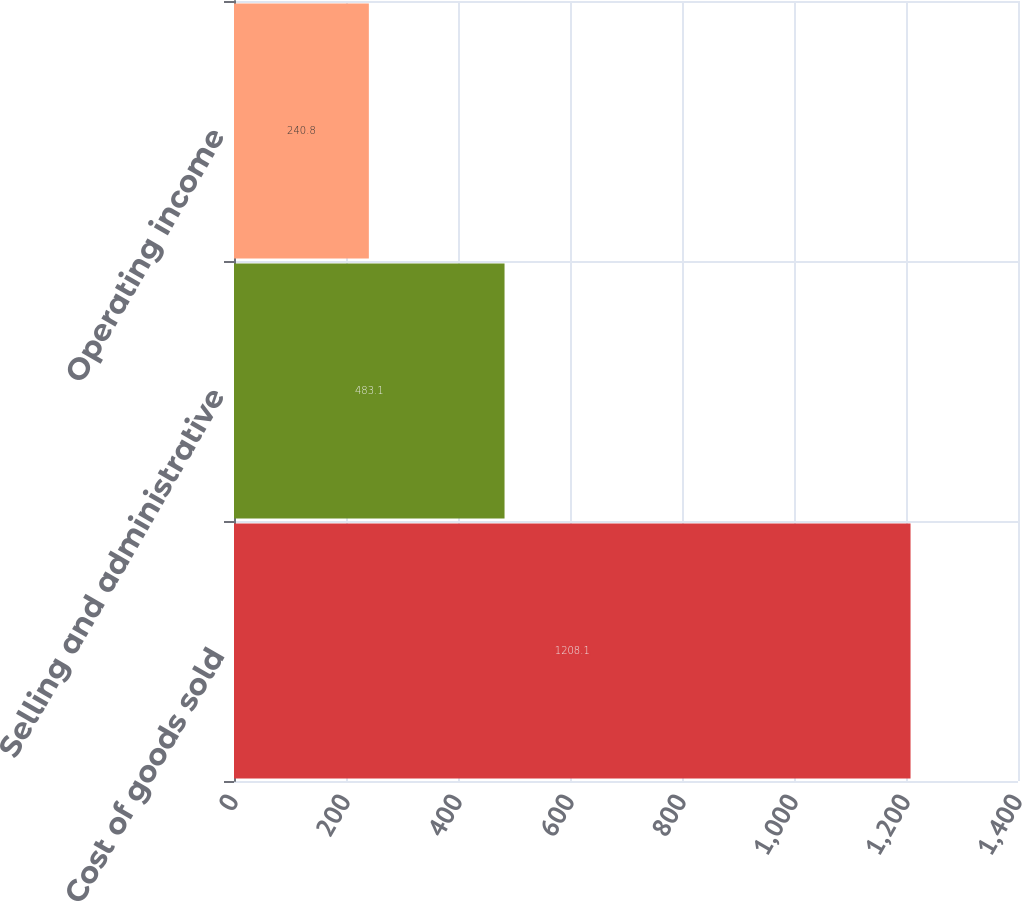<chart> <loc_0><loc_0><loc_500><loc_500><bar_chart><fcel>Cost of goods sold<fcel>Selling and administrative<fcel>Operating income<nl><fcel>1208.1<fcel>483.1<fcel>240.8<nl></chart> 